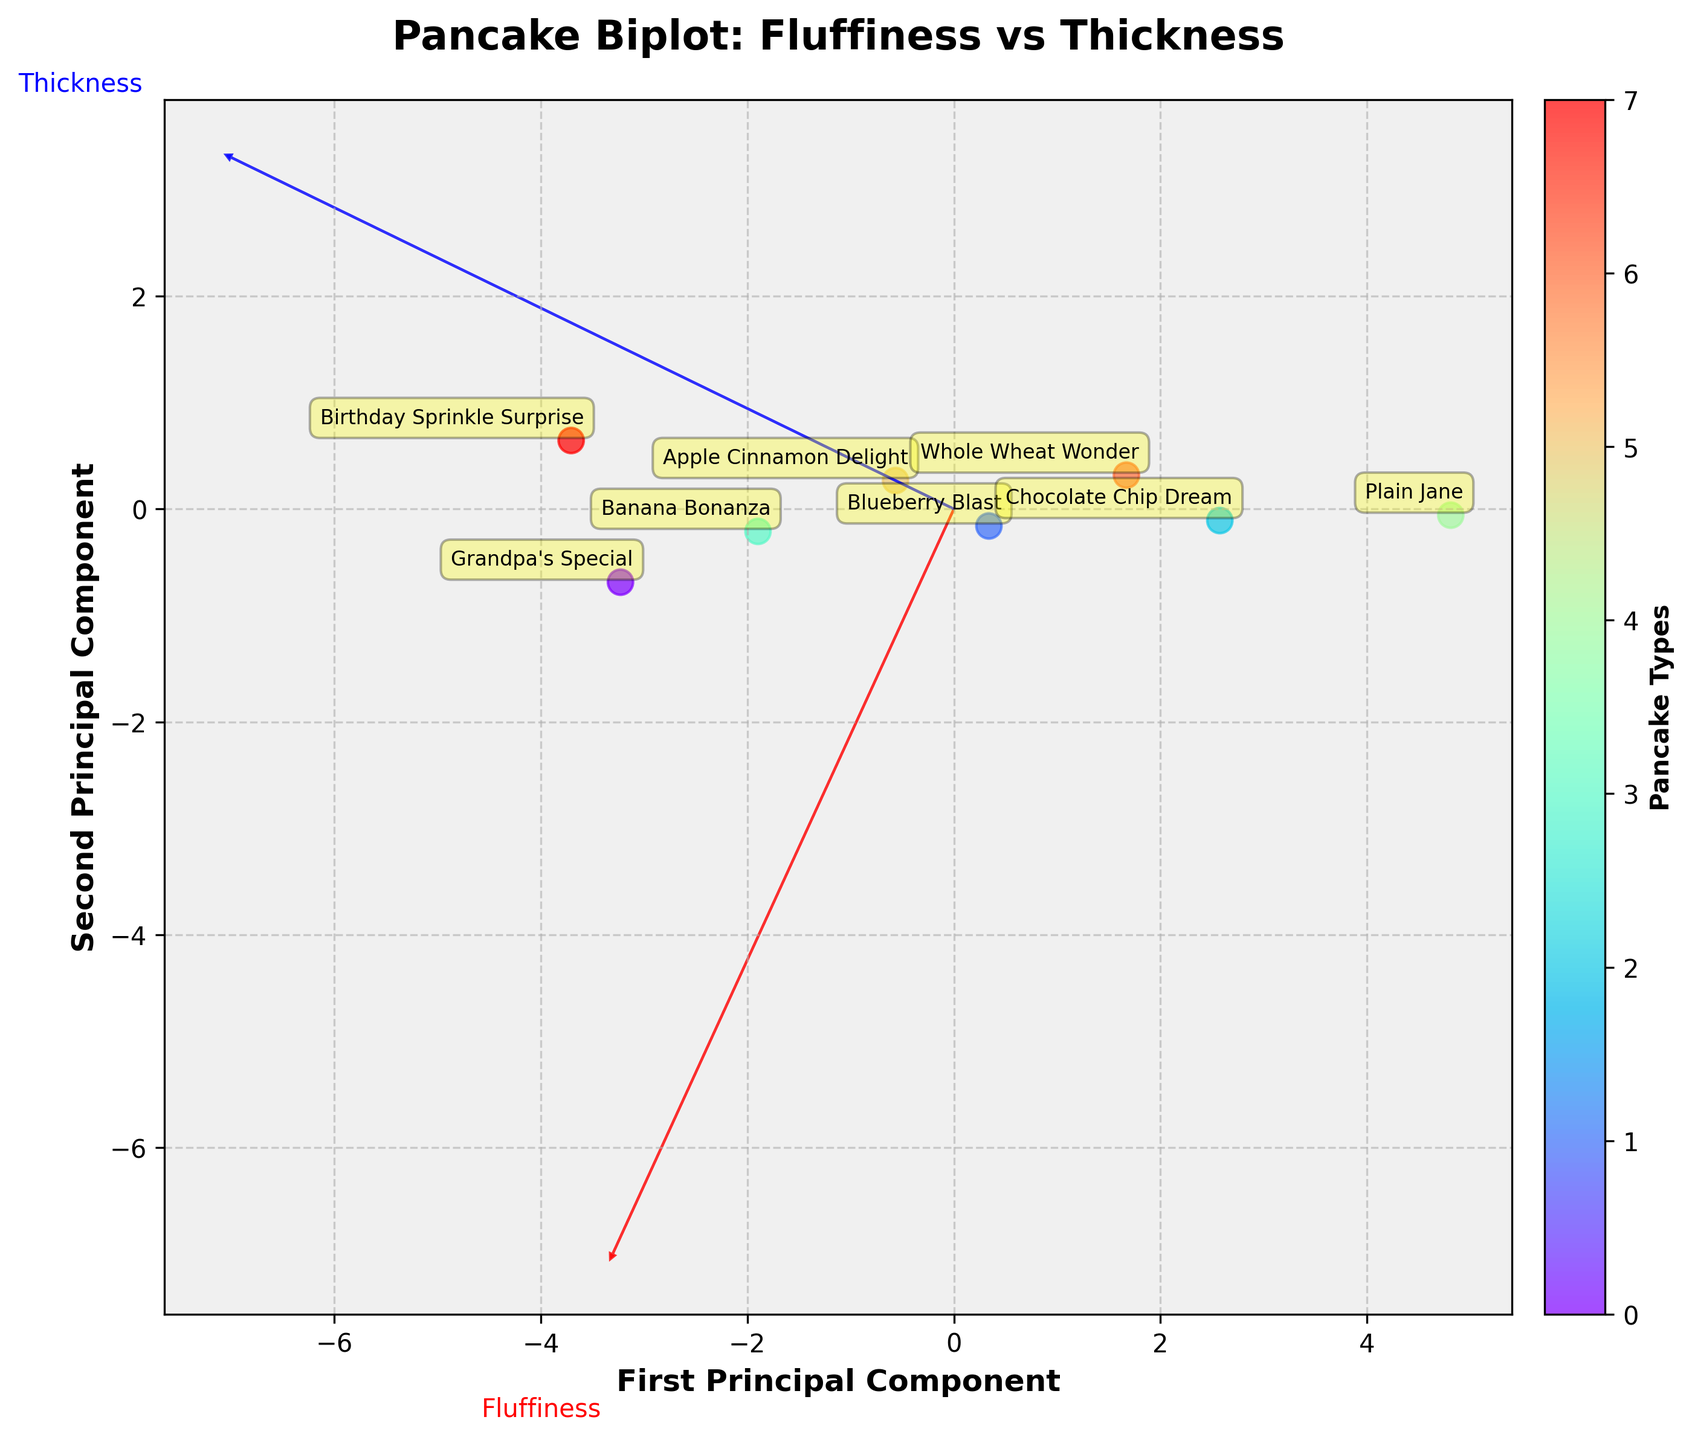Which pancake type is the fluffiest? The Pancake Type with the highest value on the Fluffiness (1-10) axis on the figure is 'Grandpa's Special' as it is projected the farthest along the Fluffiness vector.
Answer: Grandpa's Special Which pancake type has the least thickness? The data point that is positioned the least along the Thickness (mm) axis in the figure represents the 'Plain Jane' pancake type.
Answer: Plain Jane What is the relationship between the 'Blueberry Blast' and 'Apple Cinnamon Delight' in terms of their biplot positions? In the biplot, 'Blueberry Blast' (7, 12) and 'Apple Cinnamon Delight' (7, 13) have similar Fluffiness values (around 7) but slightly different Thickness values with 'Apple Cinnamon Delight' being projected to a higher Thickness component.
Answer: Similar Fluffiness; Apple Cinnamon Delight thicker Which pancake type is closest to the 'First Principal Component' axis? The pancake type closest to the First Principal Component axis is 'Plain Jane' as it lies exactly along this axis with minimal deviation.
Answer: Plain Jane Among 'Plain Jane' and 'Whole Wheat Wonder', which one has higher Fluffiness? By comparing their projections along the Fluffiness vector, 'Plain Jane' has a Fluffiness of 5 and 'Whole Wheat Wonder' has a Fluffiness of 6.
Answer: Whole Wheat Wonder How do 'Birthday Sprinkle Surprise' and 'Banana Bonanza' compare in terms of Thickness? Referencing their respective positions on the Thickness vector, 'Birthday Sprinkle Surprise' has a higher Thickness value (16 mm) compared to 'Banana Bonanza' (14 mm).
Answer: Birthday Sprinkle Surprise thicker Is there a general trend in Fluffiness as Thickness increases? By observing the overall distribution of data points, lower Thickness tends to co-occur with lower Fluffiness, and higher Thickness pairs with higher Fluffiness, indicating a positive trend.
Answer: Positive trend Which components of the biplot represent the Fluffiness and Thickness vectors? The biplot contains feature vectors where the red vector represents Fluffiness and the blue vector represents Thickness, marked with arrows and labels.
Answer: Red - Fluffiness, Blue - Thickness What can you infer about 'Chocolate Chip Dream' based on its position relative to 'Grandpa's Special'? 'Chocolate Chip Dream' is positioned with lower Fluffiness and Thickness compared to 'Grandpa's Special', indicating it is less fluffy and thinner.
Answer: Less fluffy and thinner Which pancake type is farthest from the origin and what does it imply? 'Birthday Sprinkle Surprise' is farthest from the origin along both principal components, implying high values in both Fluffiness and Thickness.
Answer: Birthday Sprinkle Surprise 